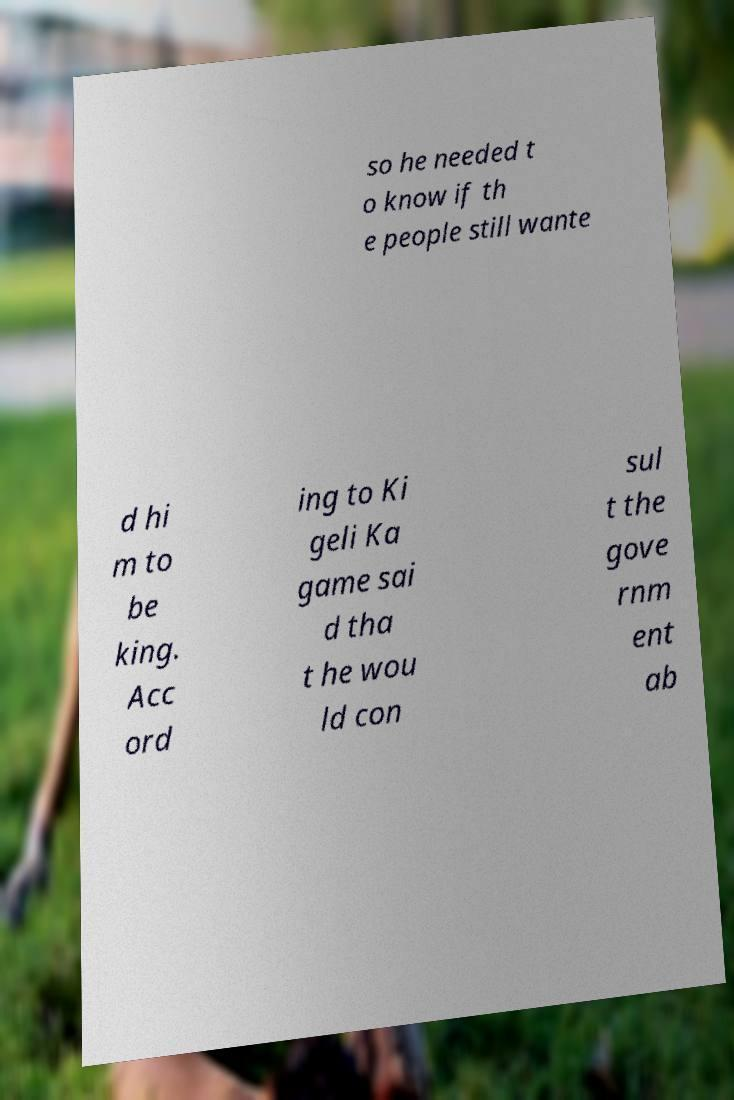What messages or text are displayed in this image? I need them in a readable, typed format. so he needed t o know if th e people still wante d hi m to be king. Acc ord ing to Ki geli Ka game sai d tha t he wou ld con sul t the gove rnm ent ab 